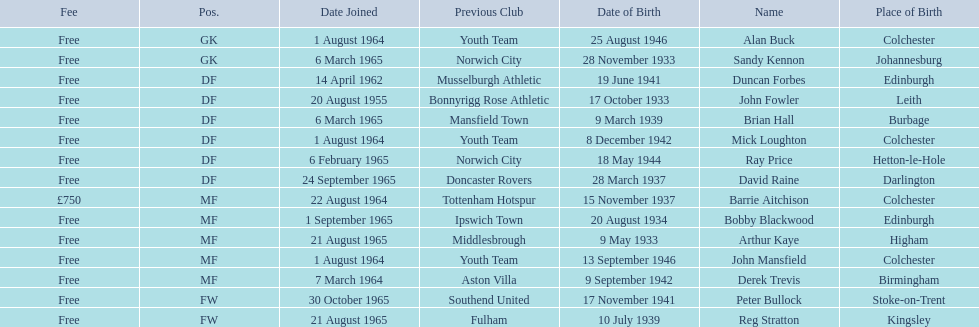When did each player join? 1 August 1964, 6 March 1965, 14 April 1962, 20 August 1955, 6 March 1965, 1 August 1964, 6 February 1965, 24 September 1965, 22 August 1964, 1 September 1965, 21 August 1965, 1 August 1964, 7 March 1964, 30 October 1965, 21 August 1965. And of those, which is the earliest join date? 20 August 1955. 